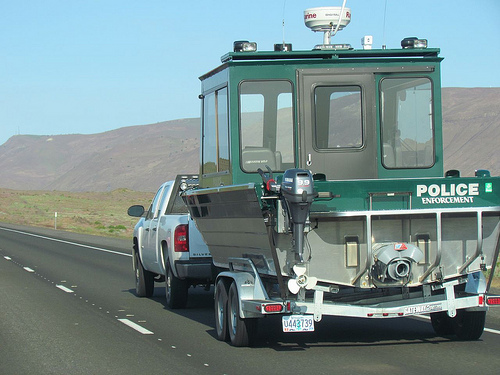<image>
Is the boat under the mountain? No. The boat is not positioned under the mountain. The vertical relationship between these objects is different. 